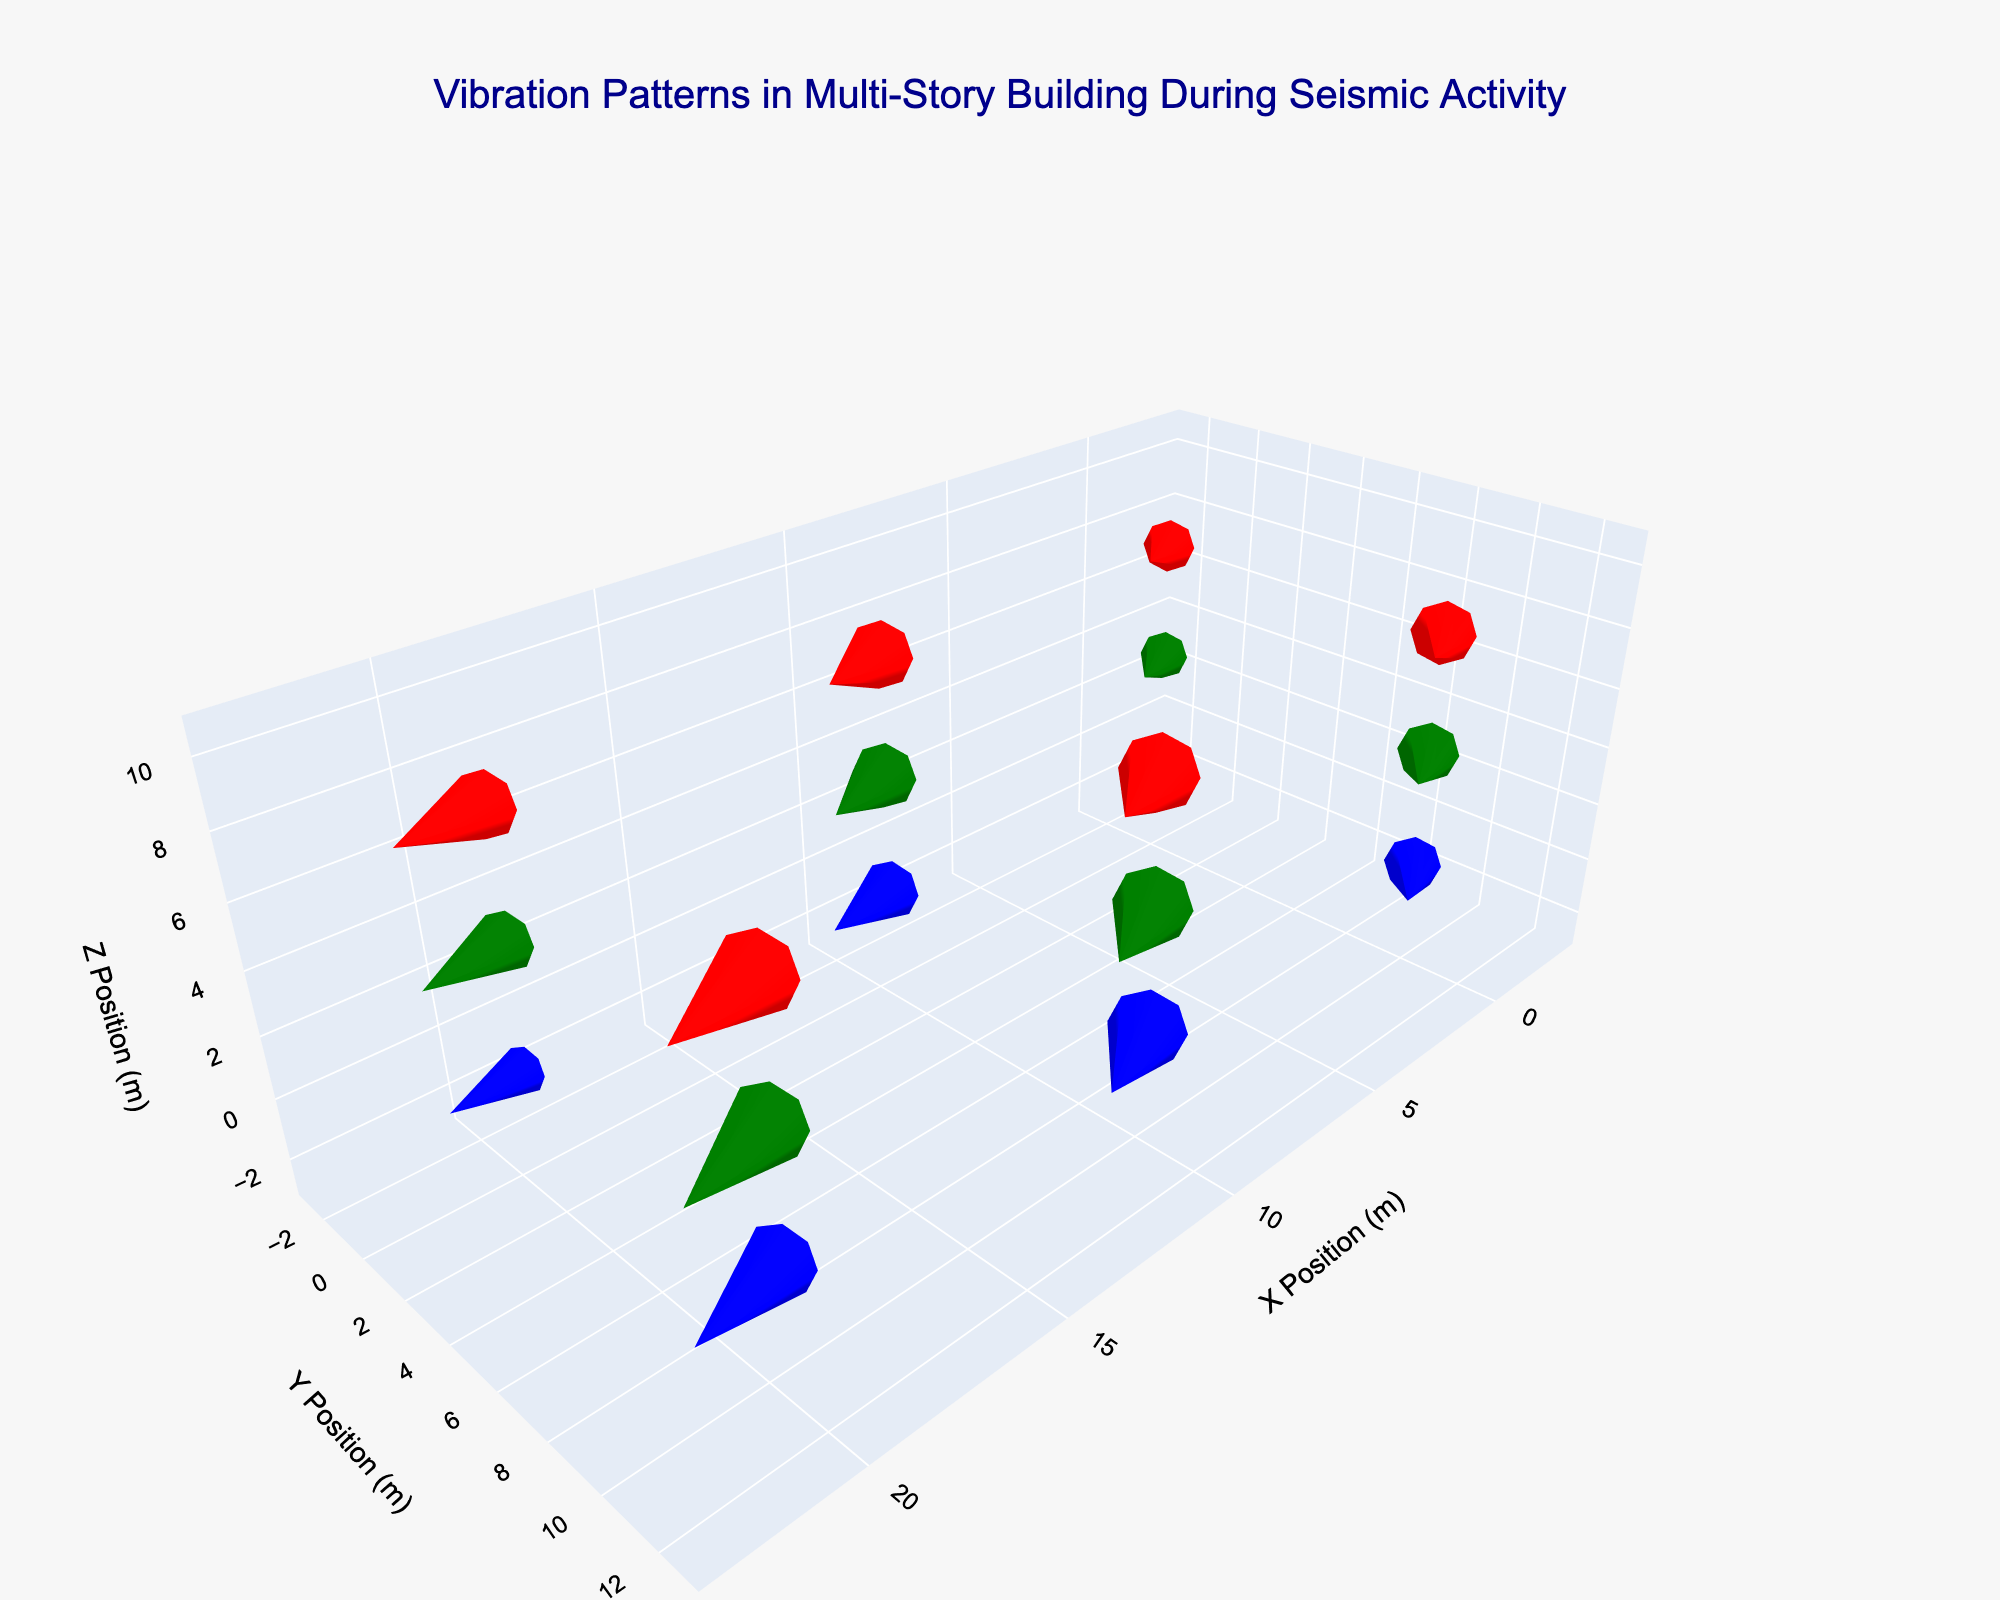How many floors are represented in the plot? The plot shows data points at different 'z' heights representing multiple floors. The legend in the plot indicates three distinct labels showing different colors namely 'Ground,' '2nd Floor,' and '4th Floor.'
Answer: Three What do the colors red, green, and blue represent in the plot? The legend in the plot specifies that different colors correspond to distinct floors. Red represents '4th Floor,' green represents '2nd Floor,' and blue represents 'Ground.'
Answer: Floor levels Which floor exhibits the highest magnitude of displacement vectors? To determine the floor with the highest magnitude of displacement vectors, compare the lengths of the vectors across the floors. The vectors lengths for each floor can be visually compared, where the 4th Floor lines (red) show the longest vectors, indicating the highest magnitude of displacement.
Answer: 4th Floor What is the general direction of the displacement vectors on the 2nd floor? Observing the direction of vectors at the 4th Floor (green), the majority of them point diagonally towards the positive x, y, and z direction.
Answer: Positive x, y, and z direction Is there a pattern in vector magnitudes as you go upward through the floors? As we go from the Ground to the 4th floor, the lengths of the vectors increase. Ground has shorter vectors, indicating smaller displacements, while the 4th-floor shows significantly longer vectors, indicating larger vibrations.
Answer: Increasing magnitude Which position has the smallest vector displacement on the Ground level? By observing the vectors on the Ground level (blue), you compare their lengths visually. The position (20, 0, 0) has the shortest vector length.
Answer: Position (20, 0, 0) Are the displacement vectors on the 4th floor larger than those on the Ground floor? A visual comparison of vector lengths between the Ground level (blue) and the 4th floor (red) shows that the 4th floor vectors are indeed longer, indicating larger displacements.
Answer: Yes What is the approximate z-displacement at position (10, 0, 8)? Examining the vector originating at position (10, 0, 8) for the 4th Floor (red), the z-component (height) of the vector is indicated by "dz" in the dataset, which is 0.16.
Answer: 0.07 Which floor has the most uniform displacement patterns? Analyzing the uniformity and directions of vectors, the Ground floor (blue) shows more uniformly directed vectors compared to the 2nd and 4th floors where variability in directions and lengths is higher.
Answer: Ground Do the directions of displacement vectors vary more on higher floors? Comparing vector directions across floors indicates that the variations in direction (and magnitude) increase as we move to higher floors, especially noticeable between the 2nd (green) and 4th (red) floors.
Answer: Yes 